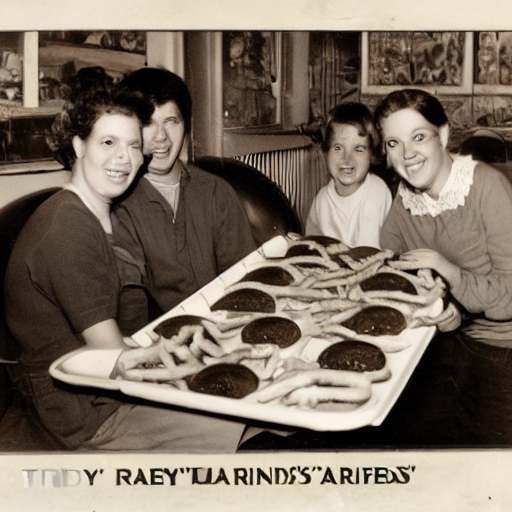Describe the emotions or vibe you get from the people in this image. The individuals in the photo exhibit a sense of joy and camaraderie, underscored by their warm smiles and close physical proximity. The presentation of the food with a sense of pride also suggests a celebratory or promotional vibe, indicating a possible special event or an advertising photo for the establishment they are in. 